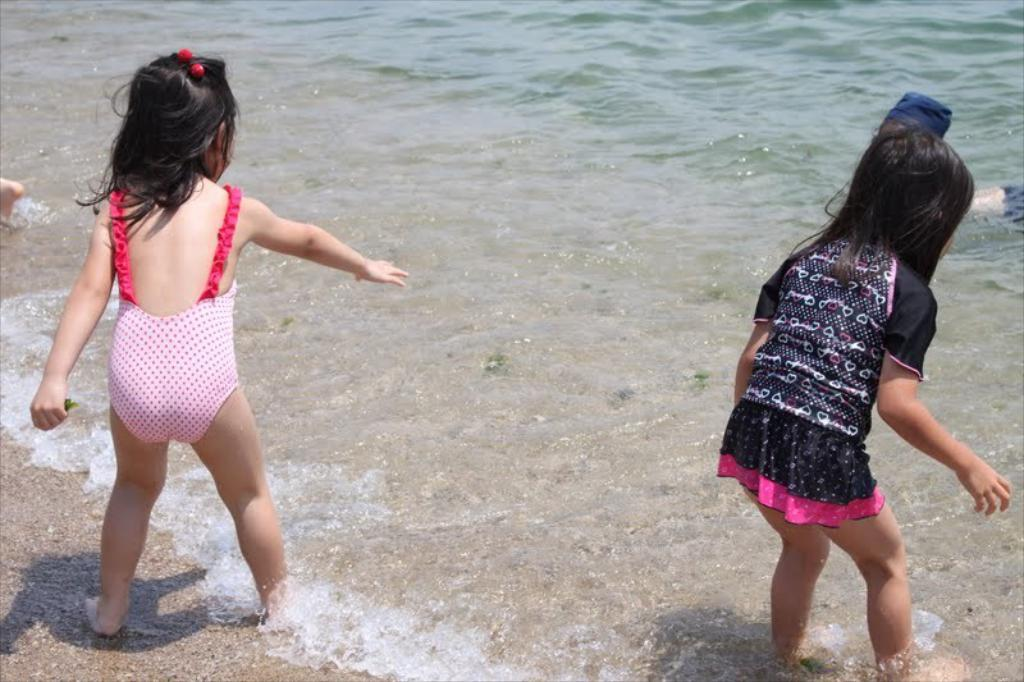How many people are in the image? There are two girls in the image. What are the girls doing in the image? The girls are standing in the water. What type of degree is the girl on the left holding in the image? There is no degree visible in the image, as the girls are standing in the water. Where is the faucet located in the image? There is no faucet present in the image; it only shows the girls standing in the water. 